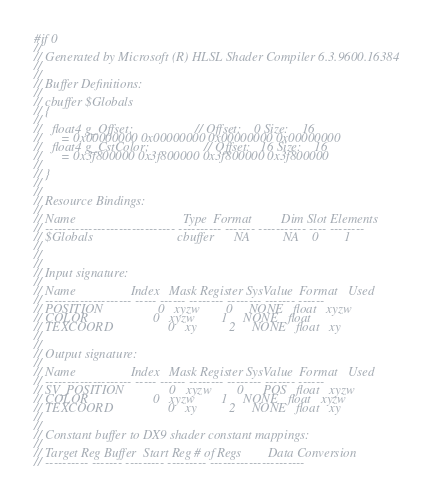<code> <loc_0><loc_0><loc_500><loc_500><_C_>#if 0
//
// Generated by Microsoft (R) HLSL Shader Compiler 6.3.9600.16384
//
//
// Buffer Definitions: 
//
// cbuffer $Globals
// {
//
//   float4 g_Offset;                   // Offset:    0 Size:    16
//      = 0x00000000 0x00000000 0x00000000 0x00000000 
//   float4 g_CstColor;                 // Offset:   16 Size:    16
//      = 0x3f800000 0x3f800000 0x3f800000 0x3f800000 
//
// }
//
//
// Resource Bindings:
//
// Name                                 Type  Format         Dim Slot Elements
// ------------------------------ ---------- ------- ----------- ---- --------
// $Globals                          cbuffer      NA          NA    0        1
//
//
//
// Input signature:
//
// Name                 Index   Mask Register SysValue  Format   Used
// -------------------- ----- ------ -------- -------- ------- ------
// POSITION                 0   xyzw        0     NONE   float   xyzw
// COLOR                    0   xyzw        1     NONE   float       
// TEXCOORD                 0   xy          2     NONE   float   xy  
//
//
// Output signature:
//
// Name                 Index   Mask Register SysValue  Format   Used
// -------------------- ----- ------ -------- -------- ------- ------
// SV_POSITION              0   xyzw        0      POS   float   xyzw
// COLOR                    0   xyzw        1     NONE   float   xyzw
// TEXCOORD                 0   xy          2     NONE   float   xy  
//
//
// Constant buffer to DX9 shader constant mappings:
//
// Target Reg Buffer  Start Reg # of Regs        Data Conversion
// ---------- ------- --------- --------- ----------------------</code> 